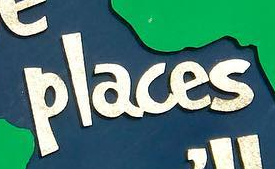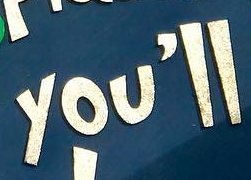What words are shown in these images in order, separated by a semicolon? places; you'll 